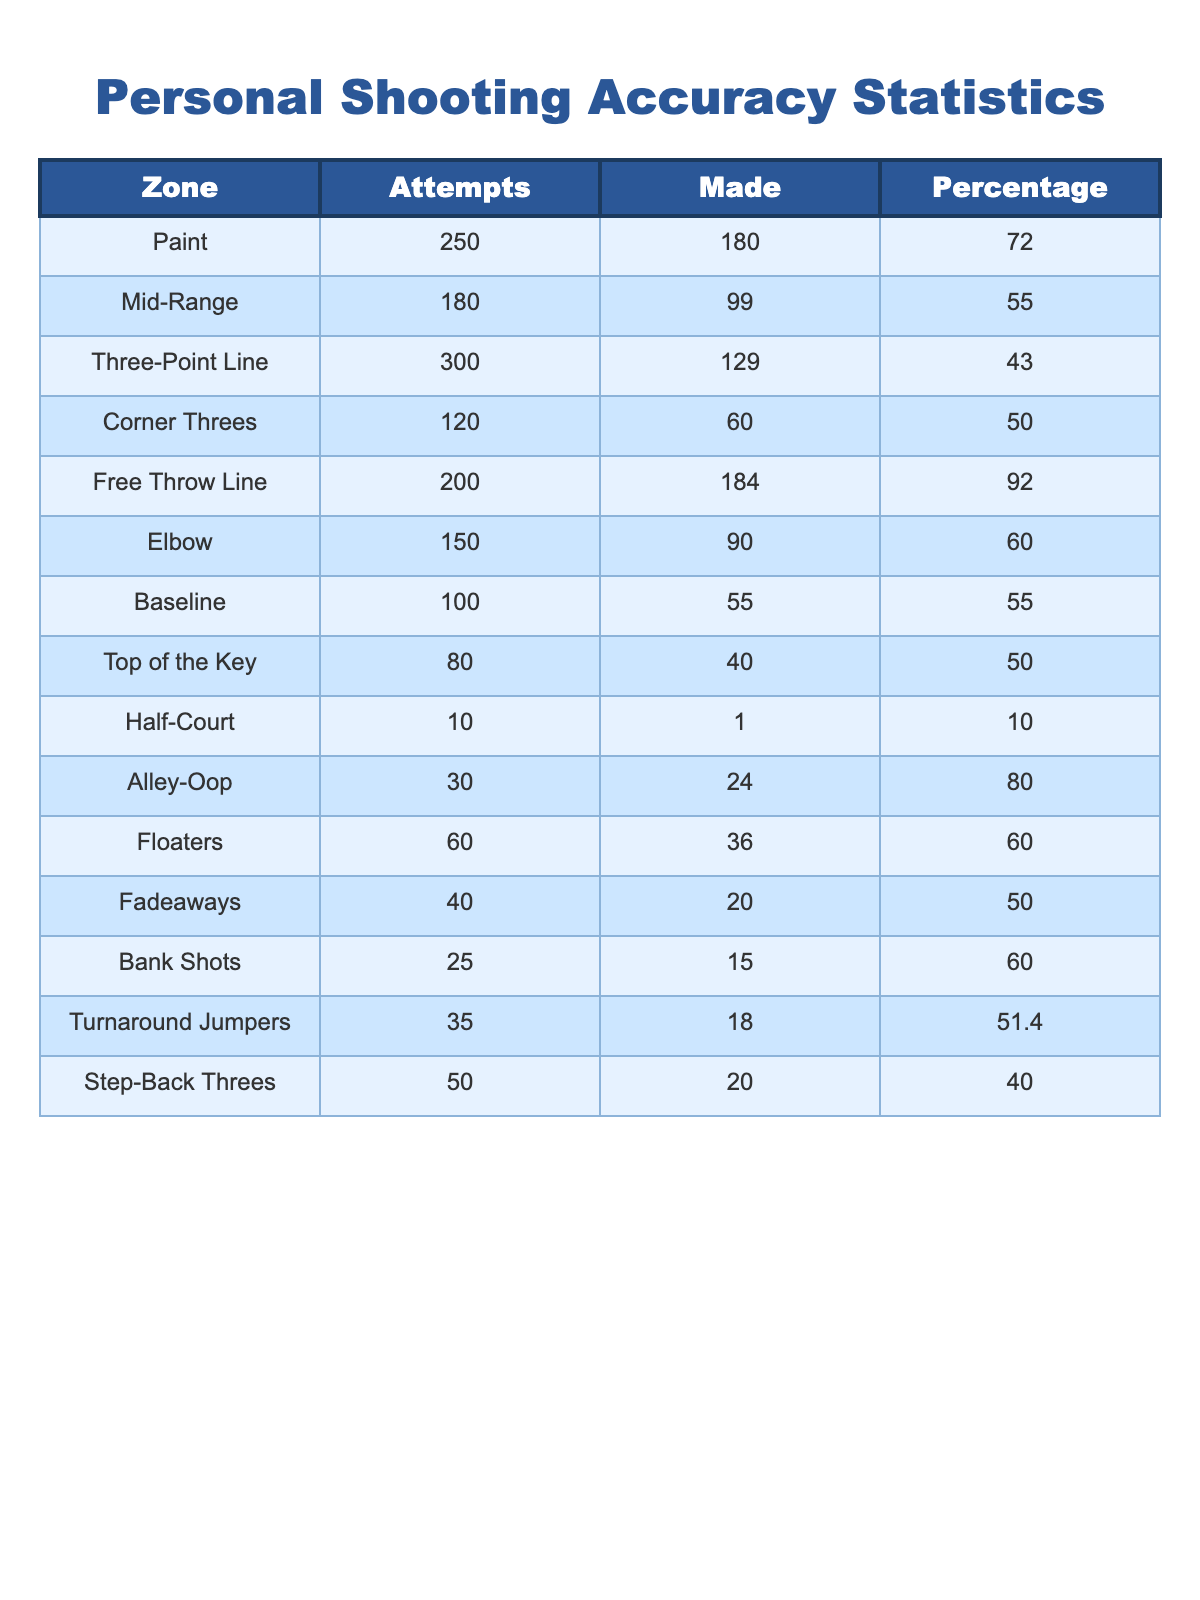What is the shooting percentage from the Free Throw Line? The table indicates that the number of shots made from the Free Throw Line is 184 out of 200 attempts. To find the percentage, divide 184 by 200 and then multiply by 100, which gives 92.0%.
Answer: 92.0% Which zone has the highest shooting percentage? Looking at the shooting percentages, the Free Throw Line has the highest percentage at 92.0%. Therefore, this zone ranks first in shooting accuracy.
Answer: Free Throw Line How many total attempts were made from the Mid-Range and Elbow zones combined? The Mid-Range attempts number 180, and the Elbow attempts number 150. Adding these together gives 180 + 150 = 330 total attempts.
Answer: 330 What is the shooting accuracy percentage for Corner Threes and how does it compare to Baseline shots? The Corner Threes have a shooting percentage of 50.0%, while the Baseline shots also have a shooting percentage of 55.0%. Since 55.0% is greater than 50.0%, Baseline shots are more accurate than Corner Threes.
Answer: Baseline shots are more accurate What is the total number of shots made from the Paint and the Alley-Oop zones? From the Paint zone, shots made are 180, and from the Alley-Oop zone, shots made are 24. Adding these two numbers gives 180 + 24 = 204 shots made in total.
Answer: 204 Is the shooting percentage from the Top of the Key better than that from the Half-Court? The Top of the Key has a shooting percentage of 50.0%, whereas the Half-Court percentage is 10.0%. Since 50.0% is greater than 10.0%, the Top of the Key shooting percentage is better than that from Half-Court.
Answer: Yes By how much does the shooting percentage of Mid-Range shots differ from the percentage of Three-Point Line shots? The Mid-Range percentage is 55.0%, and the Three-Point Line percentage is 43.0%. The difference is 55.0% - 43.0% = 12.0%. Therefore, Mid-Range shots are 12.0% more accurate than Three-Point shots.
Answer: 12.0% What is the average shooting percentage across all the zones? To find the average, sum all the percentages and divide by the number of zones (13). Adding all percentages gives 72.0 + 55.0 + 43.0 + 50.0 + 92.0 + 60.0 + 55.0 + 50.0 + 10.0 + 80.0 + 60.0 + 50.0 + 51.4 =  646.4%. Dividing this by 13 gives an average of approximately 49.7%.
Answer: 49.7% If I made 20 more shots in the Half-Court zone, what would be the new shooting percentage? The current number of shots made in Half-Court is 1 out of 10 attempts, which is a percentage of 10.0%. If 20 more shots are made and they are all successful, the new made shots would be 1 + 20 = 21, and attempts will be 10 + 20 = 30. The new percentage would be (21/30) * 100 = 70.0%.
Answer: 70.0% Which zone has the lowest percentage and how does it compare to Paint’s percentage? The Half-Court zone has the lowest shooting percentage at 10.0%. The Paint zone has a shooting percentage of 72.0%. Comparing them shows that Paint is significantly more accurate by 72.0% - 10.0% = 62.0%.
Answer: 62.0% more accurate How does the success rate of Step-Back Threes compare to that of Alley-Oop shots? The Step-Back Threes have a shooting percentage of 40.0%, while the Alley-Oop shots have a shooting percentage of 80.0%. Clearly, Alley-Oop shots are more accurate with a difference of 80.0% - 40.0% = 40.0%.
Answer: Alley-Oops are 40.0% more accurate 